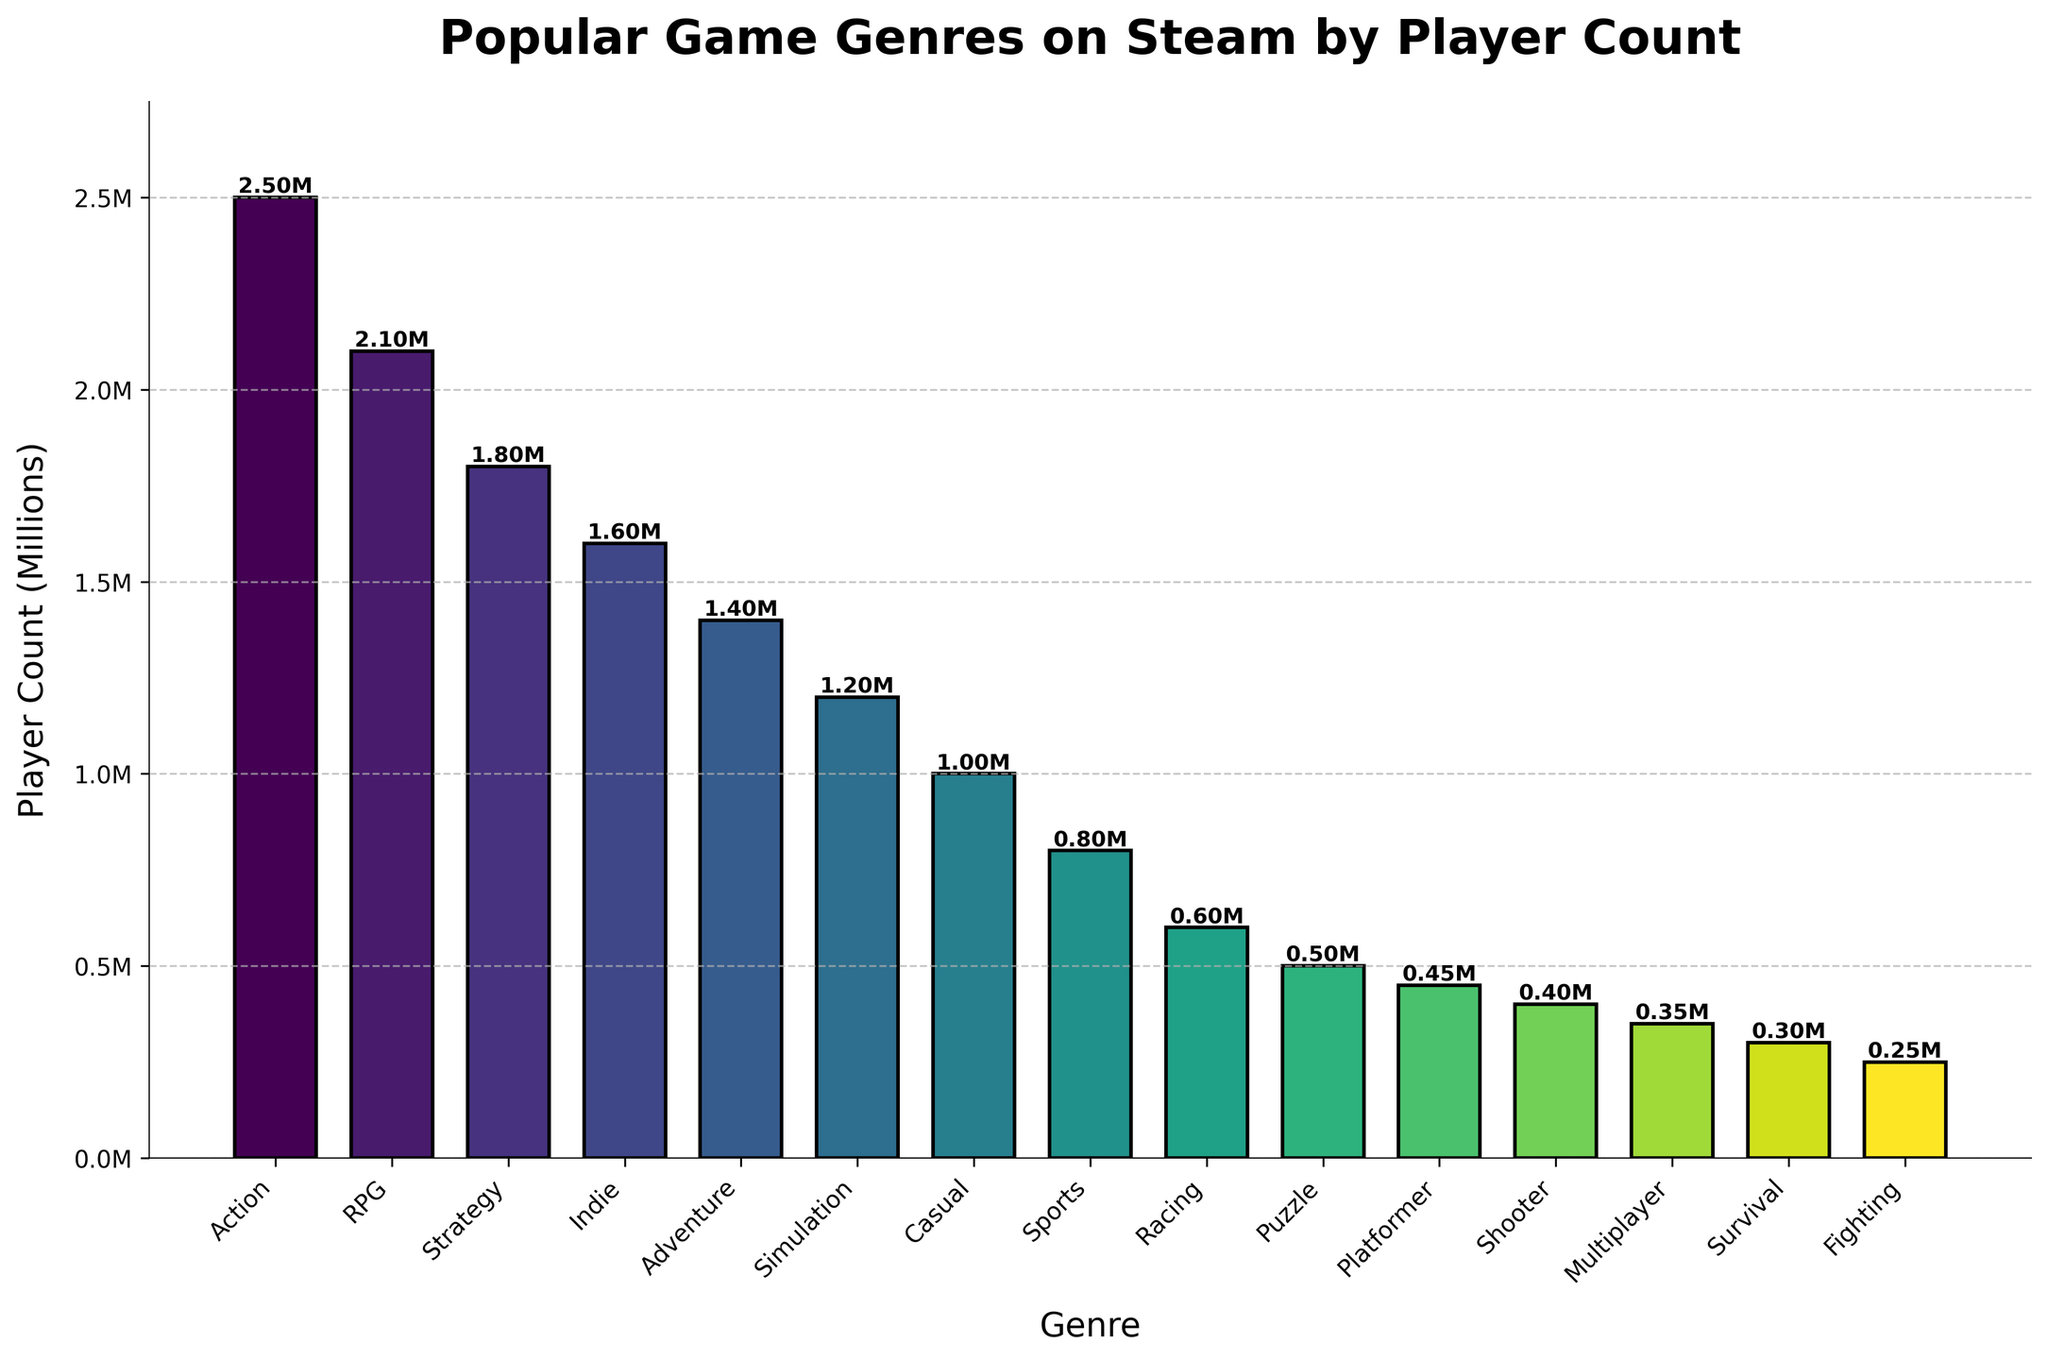Which genre has the highest player count? The tallest bar represents the genre with the highest player count. The "Action" bar is the tallest, indicating it has the highest player count.
Answer: Action Which genre has the lowest player count? The shortest bar represents the genre with the lowest player count. The "Fighting" bar is the shortest, indicating it has the lowest player count.
Answer: Fighting How does the player count for Strategy compare to RPG? Compare the heights of the "Strategy" and "RPG" bars. The "RPG" bar is taller than the "Strategy" bar, indicating RPG has a higher player count than Strategy.
Answer: RPG has more players Between Adventure and Simulation, which genre has more players? Compare the heights of the "Adventure" and "Simulation" bars. The "Adventure" bar is taller than the "Simulation" bar, meaning Adventure has more players.
Answer: Adventure What is the sum of player counts for Indie, Adventure, and Simulation? Sum the heights (player counts) of the "Indie", "Adventure", and "Simulation" bars. Indie: 1.6M, Adventure: 1.4M, Simulation: 1.2M. Total = 1.6M + 1.4M + 1.2M = 4.2M
Answer: 4.2M What is the average player count for the top 3 genres? Add the player counts of the top 3 genres (Action, RPG, Strategy) and divide by 3. Action: 2.5M, RPG: 2.1M, Strategy: 1.8M. Average = (2.5M + 2.1M + 1.8M) / 3 = 6.4M / 3 ≈ 2.13M
Answer: 2.13M By how much does the player count of Action exceed Multiplayer? Subtract the player count of "Multiplayer" from "Action". Action: 2.5M, Multiplayer: 0.35M. Difference = 2.5M - 0.35M = 2.15M
Answer: 2.15M Which genre has a player count closest to 1 million? Compare the player counts to see which one is closest to 1M. "Casual" has 1M players, which is exactly the amount being referenced.
Answer: Casual What is the total player count for all genres exceeding 1 million players? Sum the player counts of genres with more than 1 million players. Action: 2.5M, RPG: 2.1M, Strategy: 1.8M, Indie: 1.6M, Adventure: 1.4M, Simulation: 1.2M. Total = 2.5M + 2.1M + 1.8M + 1.6M + 1.4M + 1.2M = 10.6M
Answer: 10.6M 